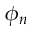Convert formula to latex. <formula><loc_0><loc_0><loc_500><loc_500>\phi _ { n }</formula> 